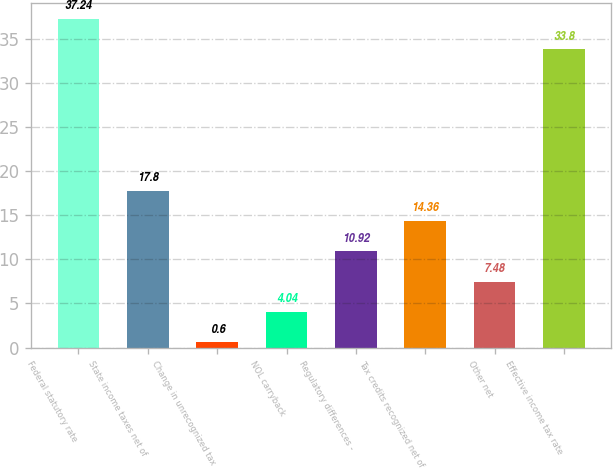Convert chart. <chart><loc_0><loc_0><loc_500><loc_500><bar_chart><fcel>Federal statutory rate<fcel>State income taxes net of<fcel>Change in unrecognized tax<fcel>NOL carryback<fcel>Regulatory differences -<fcel>Tax credits recognized net of<fcel>Other net<fcel>Effective income tax rate<nl><fcel>37.24<fcel>17.8<fcel>0.6<fcel>4.04<fcel>10.92<fcel>14.36<fcel>7.48<fcel>33.8<nl></chart> 